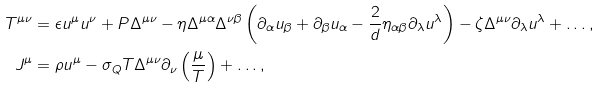<formula> <loc_0><loc_0><loc_500><loc_500>T ^ { \mu \nu } & = \epsilon u ^ { \mu } u ^ { \nu } + P \Delta ^ { \mu \nu } - \eta \Delta ^ { \mu \alpha } \Delta ^ { \nu \beta } \left ( \partial _ { \alpha } u _ { \beta } + \partial _ { \beta } u _ { \alpha } - \frac { 2 } { d } \eta _ { \alpha \beta } \partial _ { \lambda } u ^ { \lambda } \right ) - \zeta \Delta ^ { \mu \nu } \partial _ { \lambda } u ^ { \lambda } + \dots , \\ J ^ { \mu } & = \rho u ^ { \mu } - \sigma _ { Q } T \Delta ^ { \mu \nu } \partial _ { \nu } \left ( \frac { \mu } { T } \right ) + \dots ,</formula> 